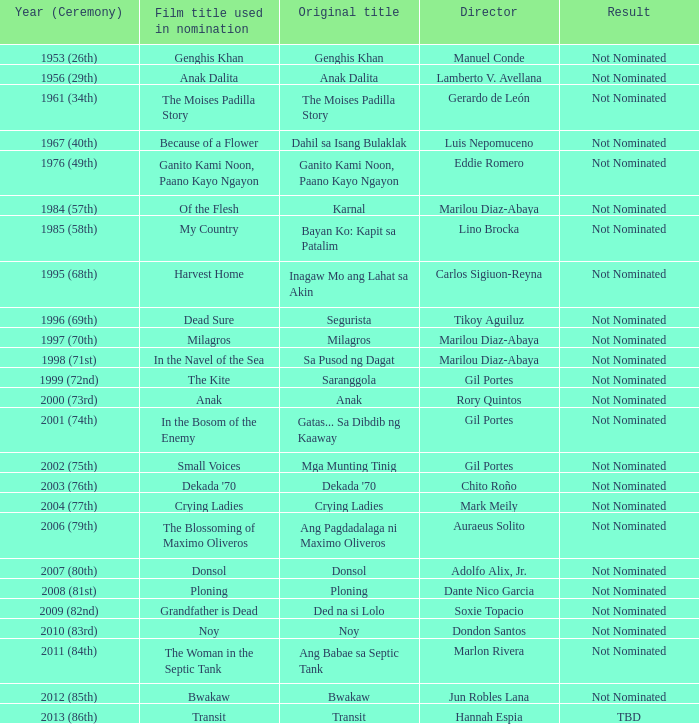What is the ceremony year when Ganito Kami Noon, Paano Kayo Ngayon was the original title? 1976 (49th). 